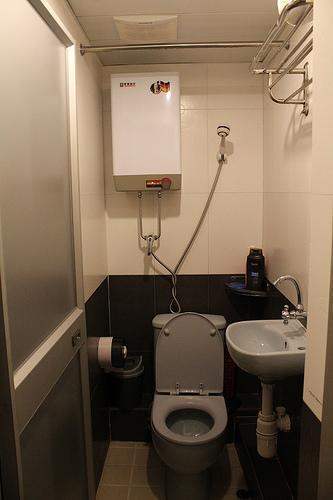How many sinks are there?
Give a very brief answer. 1. 